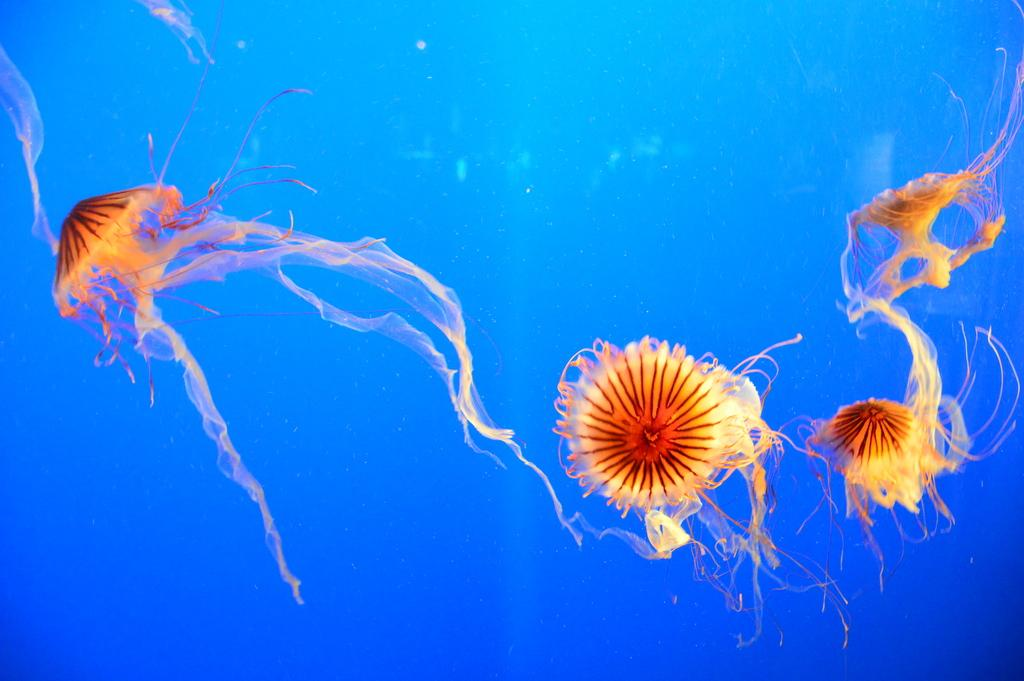What type of animals are in the image? There are jellyfishes in the image. Where are the jellyfishes located? The jellyfishes are in the water. What type of cattle can be seen grazing in the image? There is no cattle present in the image; it features jellyfishes in the water. What season is depicted in the image? The image does not depict a specific season, as it only shows jellyfishes in the water. 